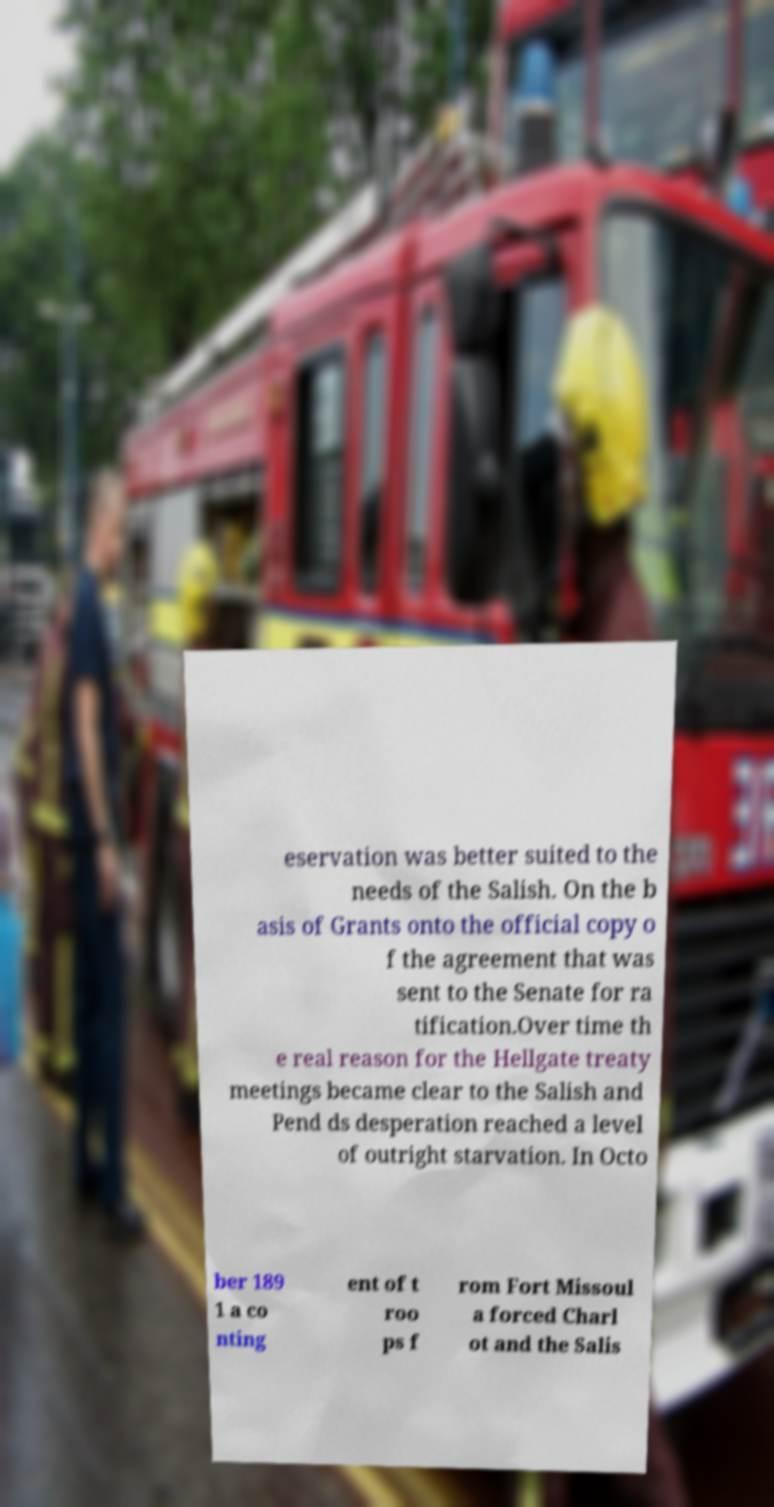Can you accurately transcribe the text from the provided image for me? eservation was better suited to the needs of the Salish. On the b asis of Grants onto the official copy o f the agreement that was sent to the Senate for ra tification.Over time th e real reason for the Hellgate treaty meetings became clear to the Salish and Pend ds desperation reached a level of outright starvation. In Octo ber 189 1 a co nting ent of t roo ps f rom Fort Missoul a forced Charl ot and the Salis 